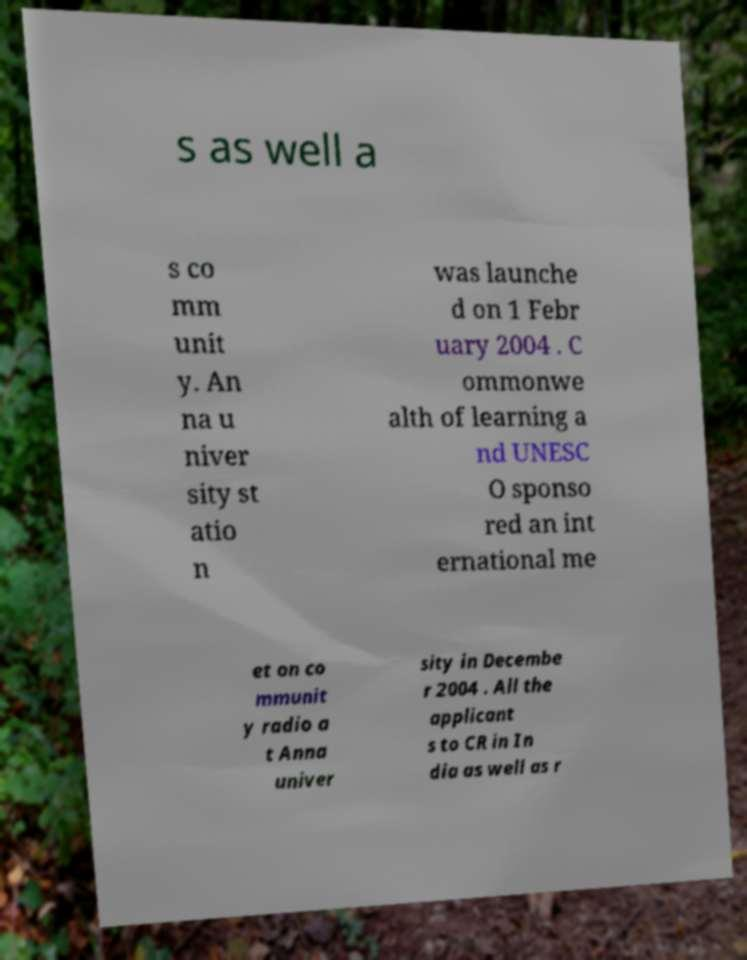I need the written content from this picture converted into text. Can you do that? s as well a s co mm unit y. An na u niver sity st atio n was launche d on 1 Febr uary 2004 . C ommonwe alth of learning a nd UNESC O sponso red an int ernational me et on co mmunit y radio a t Anna univer sity in Decembe r 2004 . All the applicant s to CR in In dia as well as r 